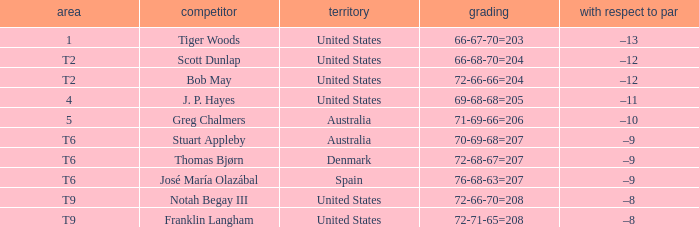Can you give me this table as a dict? {'header': ['area', 'competitor', 'territory', 'grading', 'with respect to par'], 'rows': [['1', 'Tiger Woods', 'United States', '66-67-70=203', '–13'], ['T2', 'Scott Dunlap', 'United States', '66-68-70=204', '–12'], ['T2', 'Bob May', 'United States', '72-66-66=204', '–12'], ['4', 'J. P. Hayes', 'United States', '69-68-68=205', '–11'], ['5', 'Greg Chalmers', 'Australia', '71-69-66=206', '–10'], ['T6', 'Stuart Appleby', 'Australia', '70-69-68=207', '–9'], ['T6', 'Thomas Bjørn', 'Denmark', '72-68-67=207', '–9'], ['T6', 'José María Olazábal', 'Spain', '76-68-63=207', '–9'], ['T9', 'Notah Begay III', 'United States', '72-66-70=208', '–8'], ['T9', 'Franklin Langham', 'United States', '72-71-65=208', '–8']]} What is the place of the player with a 72-71-65=208 score? T9. 